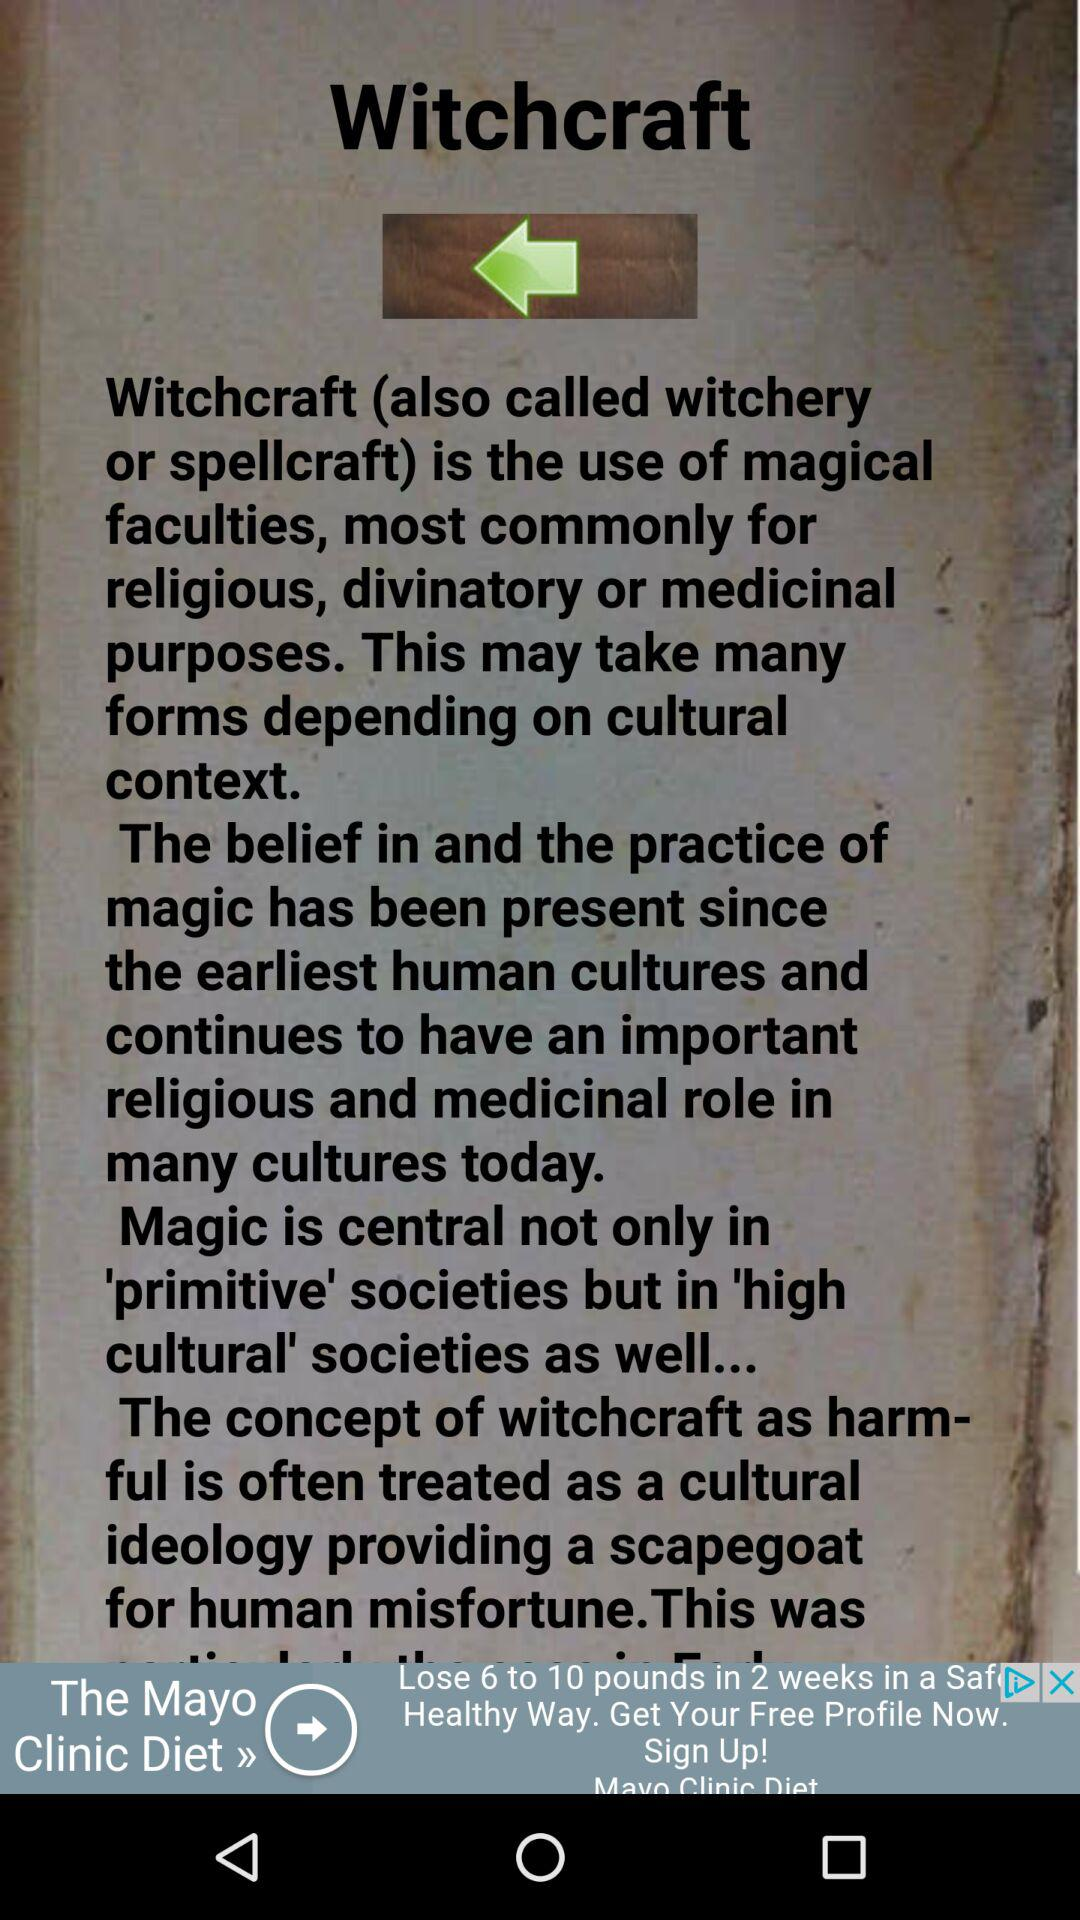What is another name for witchcraft? Another name for witchcraft is witchery or spellcraft. 